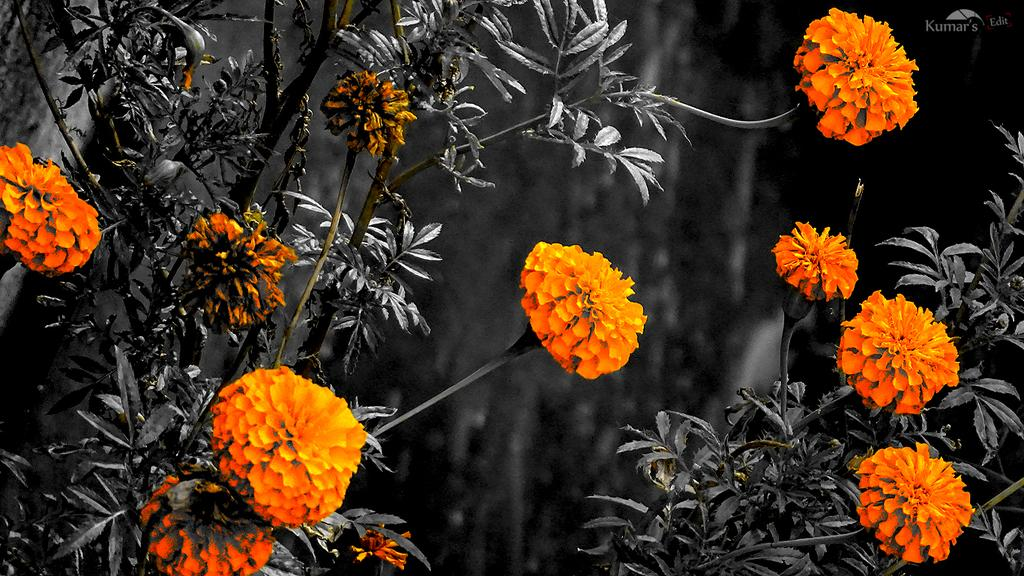What color are the flowers in the image? The flowers in the image are orange. What else can be seen in the image besides the flowers? There are leaves and plants in the image. How would you describe the background of the image? The background of the image is blurred. Is there smoke coming from the flowers in the image? No, there is no smoke present in the image. 